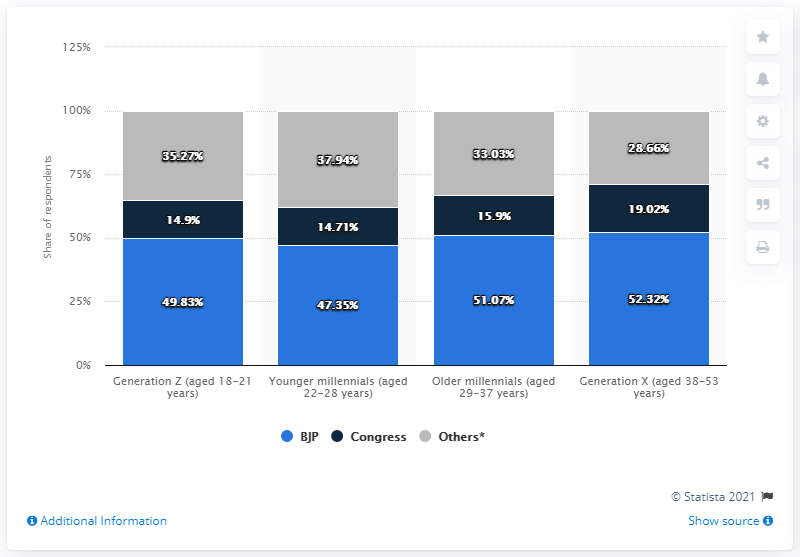Specify some key components in this picture. According to a survey conducted in February 2019, the majority of Generation Z in India supports the Bharatiya Janata Party (BJP). In February 2019, the percentage of people who supported the BJP or the Congress in the Generation X of India was 71.34. 